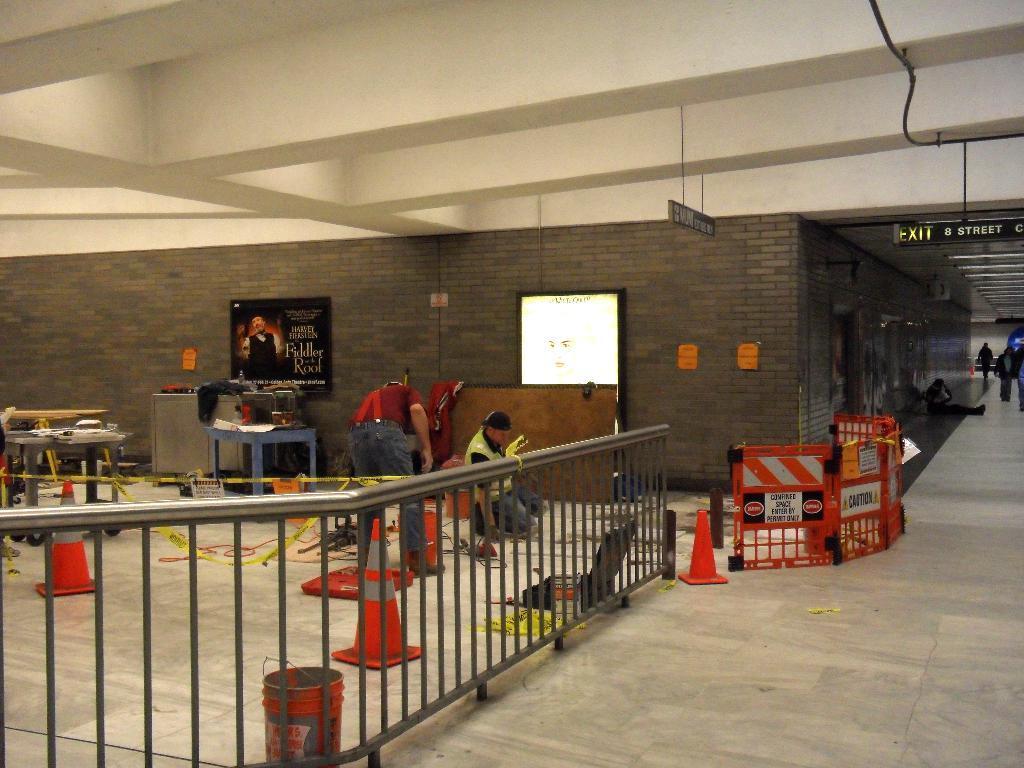In one or two sentences, can you explain what this image depicts? In this image we can see some people on the floor. We can also see the fence, a bucket, the traffic poles, wires, ribbons, some objects placed on the tables, a display screen, a board on a wall with some text on it, the sign boards and a roof with some ceiling lights. 